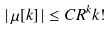<formula> <loc_0><loc_0><loc_500><loc_500>\left | \, \mu [ k ] \, \right | \leq C R ^ { k } k !</formula> 